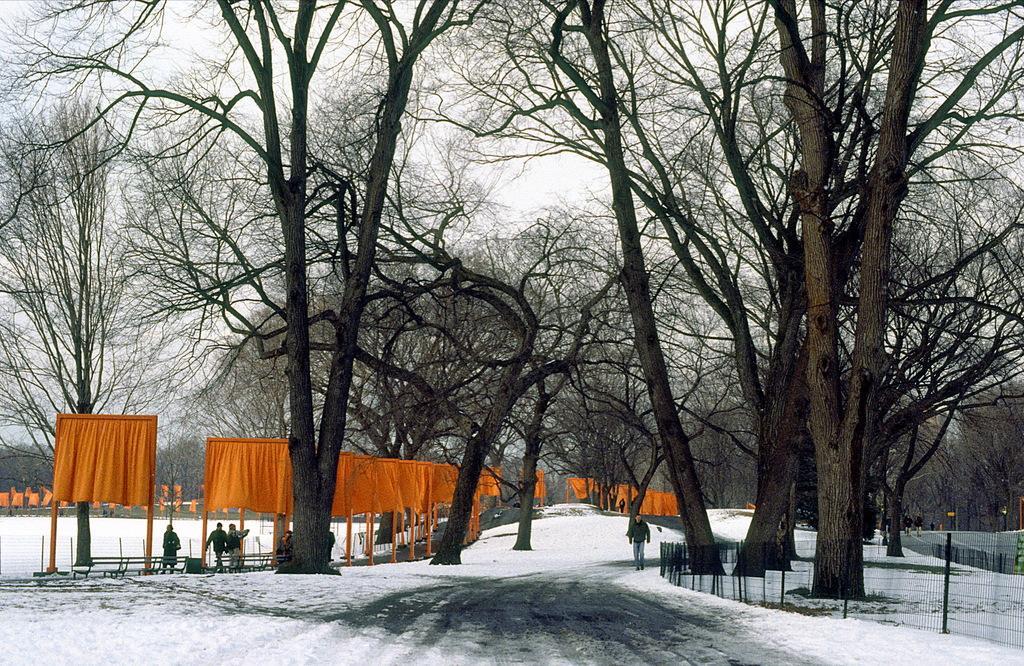Can you describe this image briefly? In this picture I can see trees and few orange color clothes to the poles and few people walking and I can see a metal fence and snow on the ground and I can see a cloudy sky. 